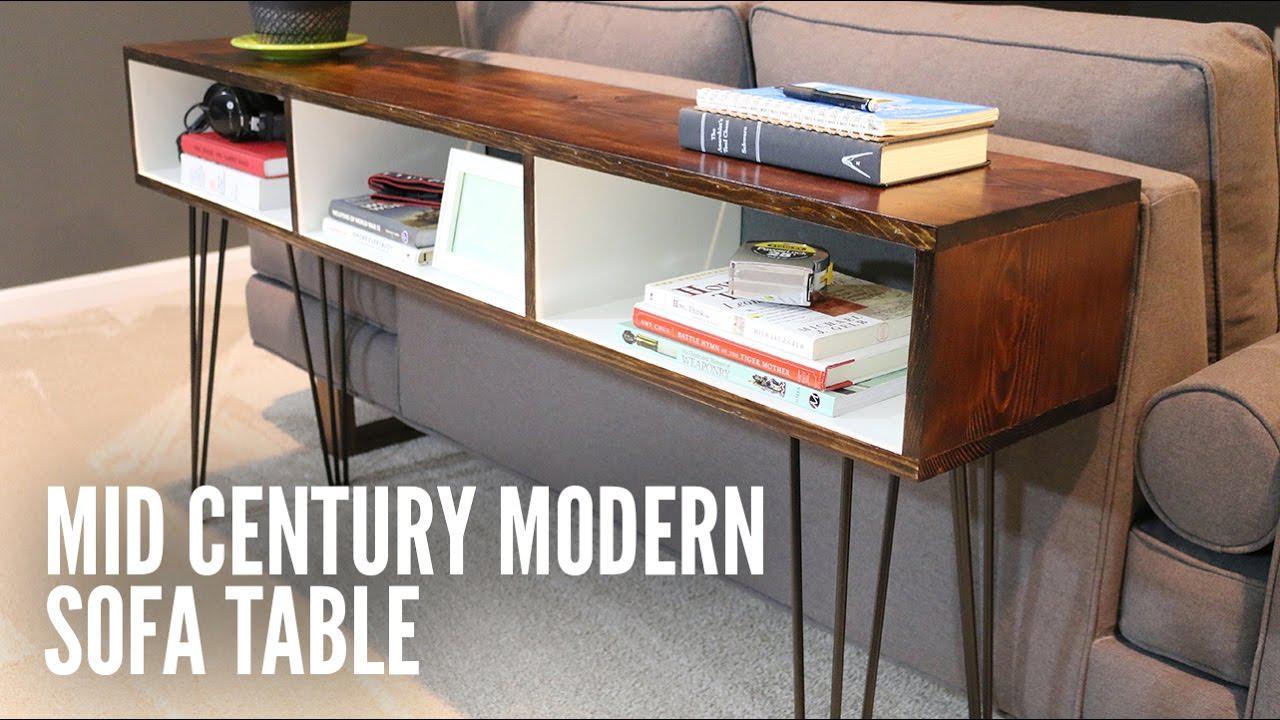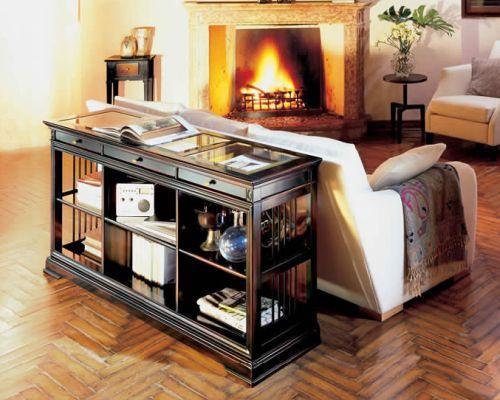The first image is the image on the left, the second image is the image on the right. Considering the images on both sides, is "In the right image the bookshelf has four different shelves with the bottom left shelf being empty." valid? Answer yes or no. No. The first image is the image on the left, the second image is the image on the right. For the images displayed, is the sentence "There is a 4 cubby bookshelf up against a sofa back with books in the shelf" factually correct? Answer yes or no. No. 